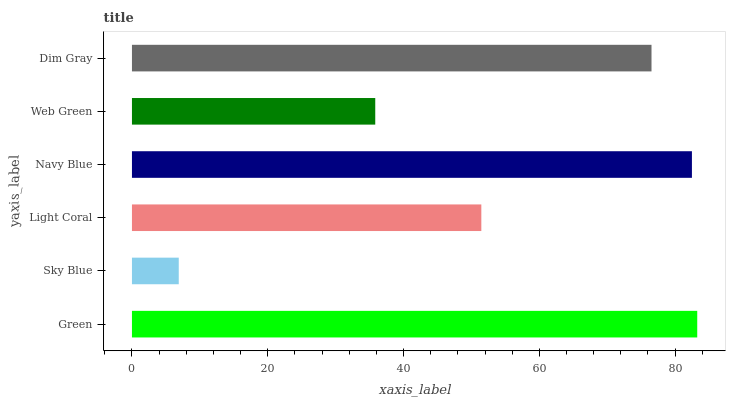Is Sky Blue the minimum?
Answer yes or no. Yes. Is Green the maximum?
Answer yes or no. Yes. Is Light Coral the minimum?
Answer yes or no. No. Is Light Coral the maximum?
Answer yes or no. No. Is Light Coral greater than Sky Blue?
Answer yes or no. Yes. Is Sky Blue less than Light Coral?
Answer yes or no. Yes. Is Sky Blue greater than Light Coral?
Answer yes or no. No. Is Light Coral less than Sky Blue?
Answer yes or no. No. Is Dim Gray the high median?
Answer yes or no. Yes. Is Light Coral the low median?
Answer yes or no. Yes. Is Green the high median?
Answer yes or no. No. Is Green the low median?
Answer yes or no. No. 